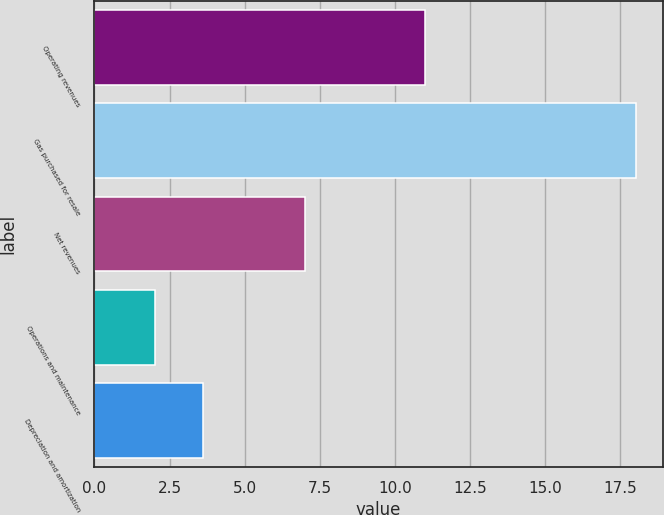Convert chart. <chart><loc_0><loc_0><loc_500><loc_500><bar_chart><fcel>Operating revenues<fcel>Gas purchased for resale<fcel>Net revenues<fcel>Operations and maintenance<fcel>Depreciation and amortization<nl><fcel>11<fcel>18<fcel>7<fcel>2<fcel>3.6<nl></chart> 